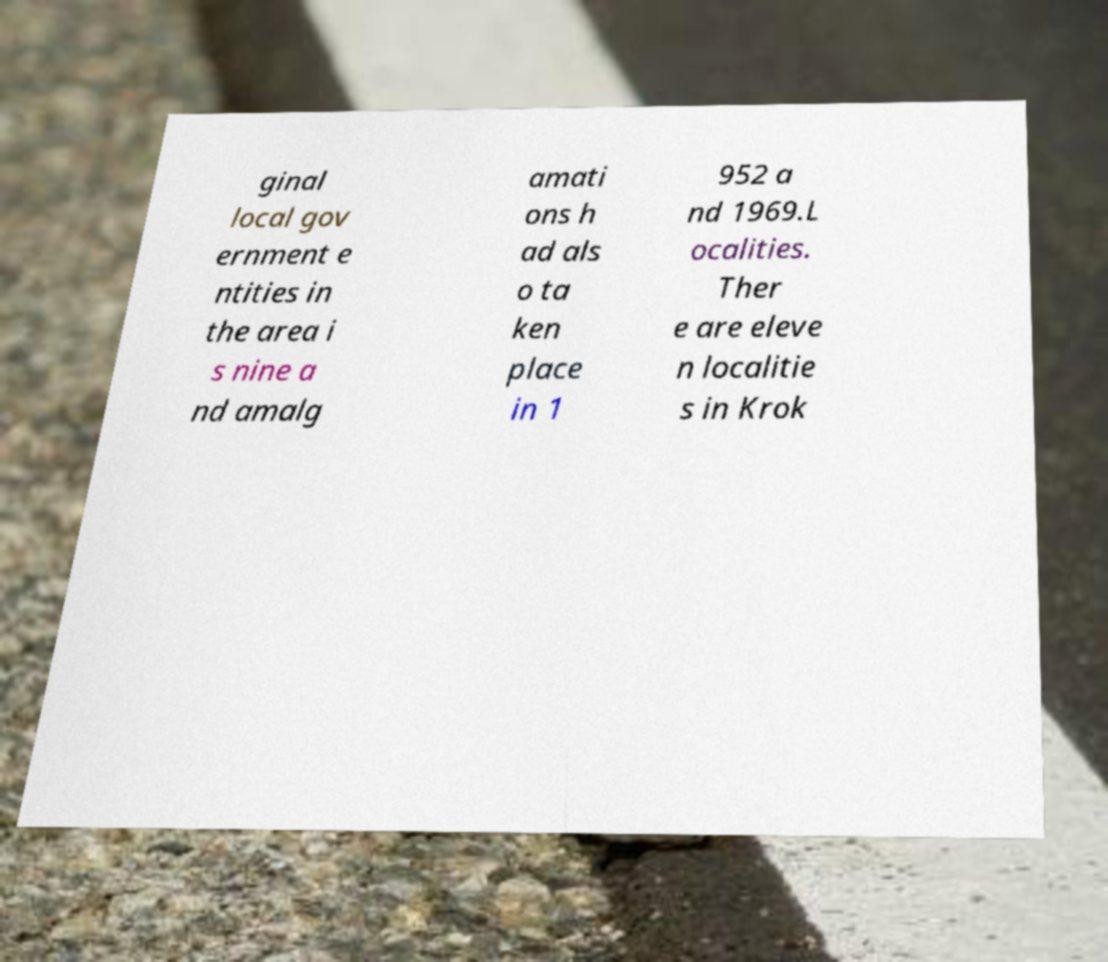Please identify and transcribe the text found in this image. ginal local gov ernment e ntities in the area i s nine a nd amalg amati ons h ad als o ta ken place in 1 952 a nd 1969.L ocalities. Ther e are eleve n localitie s in Krok 